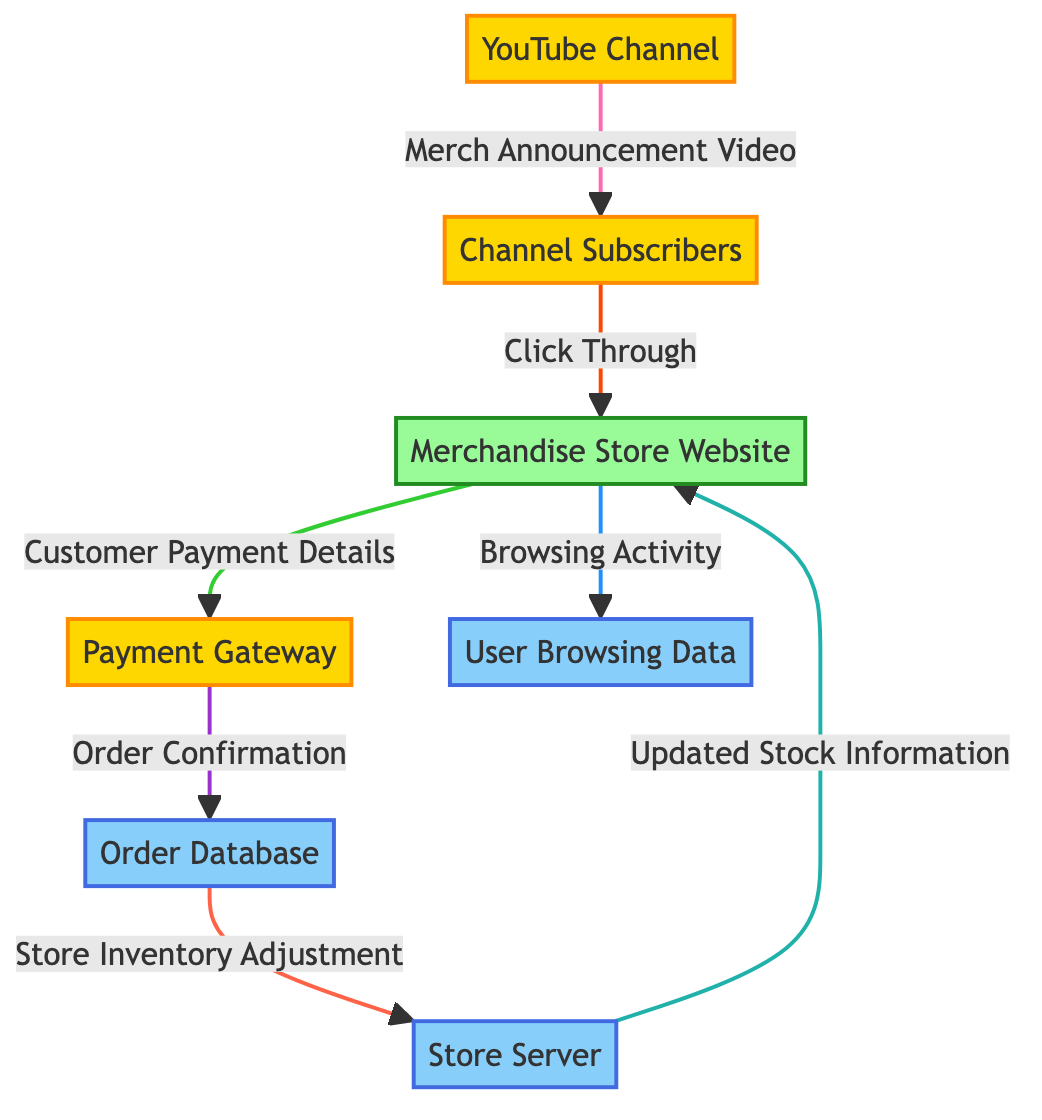What's the external entity that interacts with the YouTube Channel? The diagram shows that the "Channel Subscribers" is an external entity that interacts with the YouTube Channel by receiving the "Merch Announcement Video."
Answer: Channel Subscribers How many data flows are present in the diagram? To find the number of data flows, we count each arrow representing the transfer of data. There are a total of 6 distinct data flows in the diagram.
Answer: 6 What data does the Payment Gateway receive from the Merchandise Store Website? According to the diagram, the Payment Gateway receives "Customer Payment Details" from the Merchandise Store Website, which is indicated by the data flow arrow between these two nodes.
Answer: Customer Payment Details Which entity is responsible for order confirmation? The diagram shows that the "Order Database" is responsible for receiving the "Order Confirmation" from the Payment Gateway. This indicates the Order Database's role in confirming orders.
Answer: Order Database What is transferred from the Store Server to the Merchandise Store Website? The Store Server sends "Updated Stock Information" back to the Merchandise Store Website, as outlined in the data flow from the Store Server to the Merchandise Store Website.
Answer: Updated Stock Information What type of entity is the Merchandise Store Website? The diagram classifies the Merchandise Store Website as a "process," which indicates its role in facilitating transactions and interactions with other entities.
Answer: process What triggers the click through to the Merchandise Store Website? The action that triggers the click through is the "Merch Announcement Video," which is provided by the YouTube Channel to the Channel Subscribers.
Answer: Merch Announcement Video What happens to the store inventory after an order is confirmed? According to the diagram, once an order is confirmed in the Order Database, a "Store Inventory Adjustment" occurs, which indicates inventory management following an order placement.
Answer: Store Inventory Adjustment 